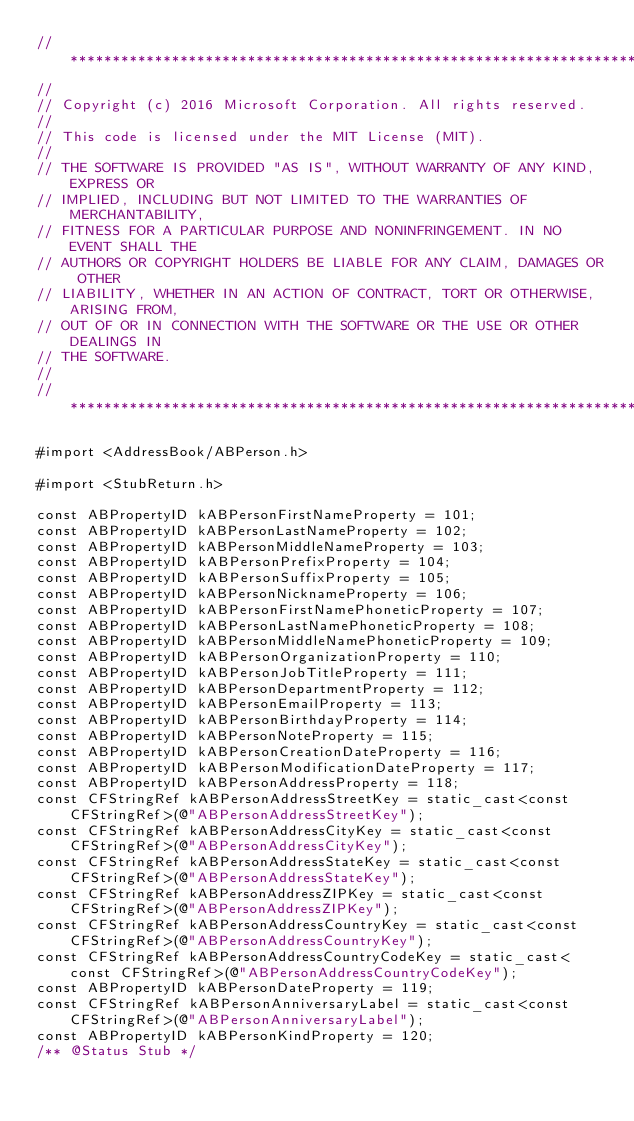Convert code to text. <code><loc_0><loc_0><loc_500><loc_500><_ObjectiveC_>//******************************************************************************
//
// Copyright (c) 2016 Microsoft Corporation. All rights reserved.
//
// This code is licensed under the MIT License (MIT).
//
// THE SOFTWARE IS PROVIDED "AS IS", WITHOUT WARRANTY OF ANY KIND, EXPRESS OR
// IMPLIED, INCLUDING BUT NOT LIMITED TO THE WARRANTIES OF MERCHANTABILITY,
// FITNESS FOR A PARTICULAR PURPOSE AND NONINFRINGEMENT. IN NO EVENT SHALL THE
// AUTHORS OR COPYRIGHT HOLDERS BE LIABLE FOR ANY CLAIM, DAMAGES OR OTHER
// LIABILITY, WHETHER IN AN ACTION OF CONTRACT, TORT OR OTHERWISE, ARISING FROM,
// OUT OF OR IN CONNECTION WITH THE SOFTWARE OR THE USE OR OTHER DEALINGS IN
// THE SOFTWARE.
//
//******************************************************************************

#import <AddressBook/ABPerson.h>

#import <StubReturn.h>

const ABPropertyID kABPersonFirstNameProperty = 101;
const ABPropertyID kABPersonLastNameProperty = 102;
const ABPropertyID kABPersonMiddleNameProperty = 103;
const ABPropertyID kABPersonPrefixProperty = 104;
const ABPropertyID kABPersonSuffixProperty = 105;
const ABPropertyID kABPersonNicknameProperty = 106;
const ABPropertyID kABPersonFirstNamePhoneticProperty = 107;
const ABPropertyID kABPersonLastNamePhoneticProperty = 108;
const ABPropertyID kABPersonMiddleNamePhoneticProperty = 109;
const ABPropertyID kABPersonOrganizationProperty = 110;
const ABPropertyID kABPersonJobTitleProperty = 111;
const ABPropertyID kABPersonDepartmentProperty = 112;
const ABPropertyID kABPersonEmailProperty = 113;
const ABPropertyID kABPersonBirthdayProperty = 114;
const ABPropertyID kABPersonNoteProperty = 115;
const ABPropertyID kABPersonCreationDateProperty = 116;
const ABPropertyID kABPersonModificationDateProperty = 117;
const ABPropertyID kABPersonAddressProperty = 118;
const CFStringRef kABPersonAddressStreetKey = static_cast<const CFStringRef>(@"ABPersonAddressStreetKey");
const CFStringRef kABPersonAddressCityKey = static_cast<const CFStringRef>(@"ABPersonAddressCityKey");
const CFStringRef kABPersonAddressStateKey = static_cast<const CFStringRef>(@"ABPersonAddressStateKey");
const CFStringRef kABPersonAddressZIPKey = static_cast<const CFStringRef>(@"ABPersonAddressZIPKey");
const CFStringRef kABPersonAddressCountryKey = static_cast<const CFStringRef>(@"ABPersonAddressCountryKey");
const CFStringRef kABPersonAddressCountryCodeKey = static_cast<const CFStringRef>(@"ABPersonAddressCountryCodeKey");
const ABPropertyID kABPersonDateProperty = 119;
const CFStringRef kABPersonAnniversaryLabel = static_cast<const CFStringRef>(@"ABPersonAnniversaryLabel");
const ABPropertyID kABPersonKindProperty = 120;
/** @Status Stub */</code> 